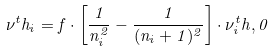Convert formula to latex. <formula><loc_0><loc_0><loc_500><loc_500>\nu ^ { t } h _ { i } = f \cdot \left [ \frac { 1 } { n _ { i } ^ { 2 } } - \frac { 1 } { ( n _ { i } + 1 ) ^ { 2 } } \right ] \cdot \nu _ { i } ^ { t } h , 0</formula> 